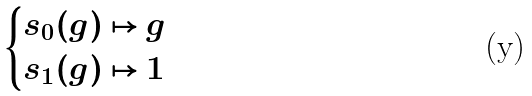<formula> <loc_0><loc_0><loc_500><loc_500>\begin{cases} s _ { 0 } ( g ) \mapsto g \\ s _ { 1 } ( g ) \mapsto 1 \end{cases}</formula> 